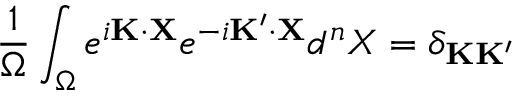<formula> <loc_0><loc_0><loc_500><loc_500>\frac { 1 } { \Omega } \int _ { \Omega } e ^ { i { K } \cdot { X } } e ^ { - i { K ^ { \prime } } \cdot { X } } d ^ { n } X = \delta _ { { K } { K } ^ { \prime } }</formula> 